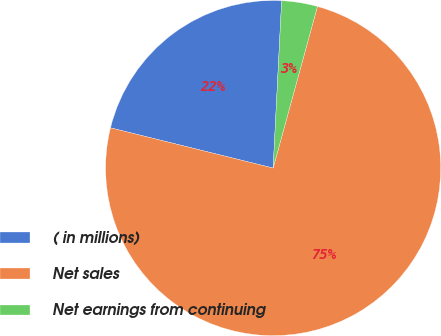Convert chart. <chart><loc_0><loc_0><loc_500><loc_500><pie_chart><fcel>( in millions)<fcel>Net sales<fcel>Net earnings from continuing<nl><fcel>21.95%<fcel>74.61%<fcel>3.45%<nl></chart> 